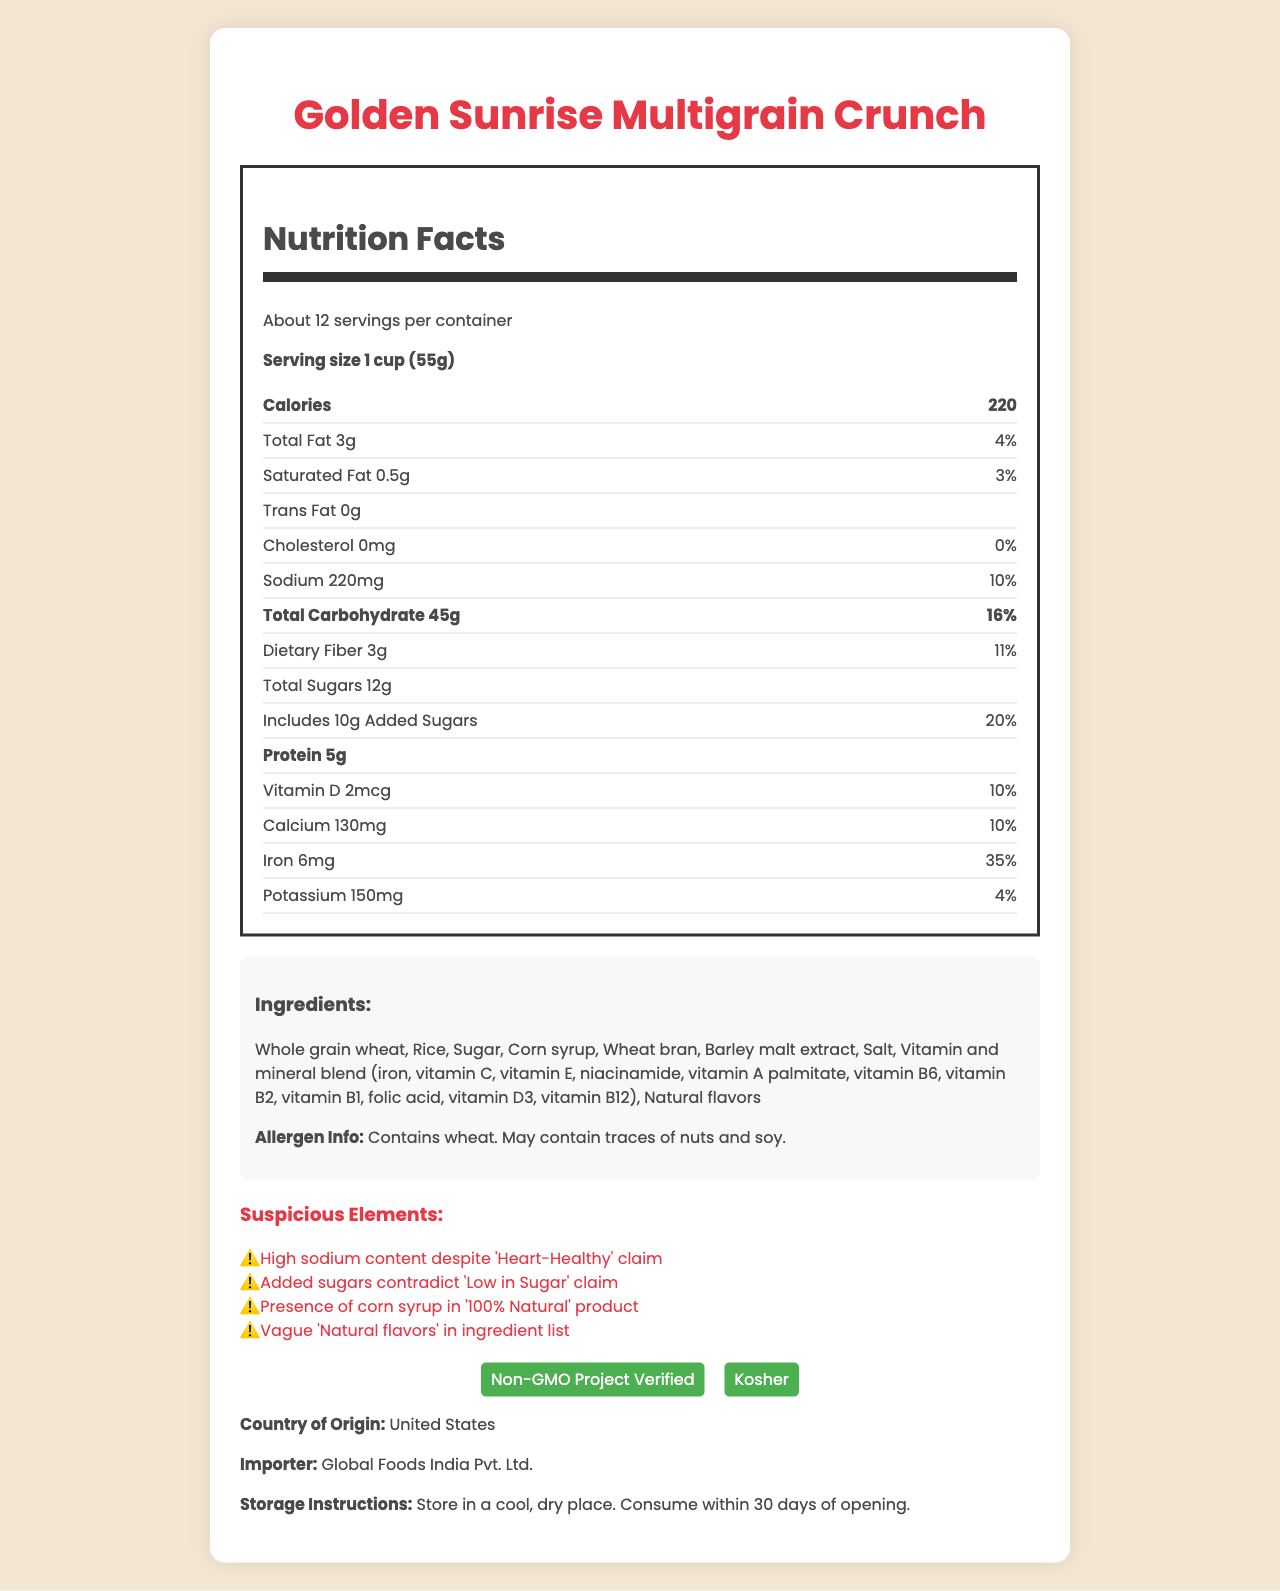what is the serving size of Golden Sunrise Multigrain Crunch? The nutrition label at the top of the document lists the serving size as "1 cup (55g)".
Answer: 1 cup (55g) how many calories are in one serving? The document states in the nutrition label section, under the heading "Calories", that each serving has 220 calories.
Answer: 220 name two certifications the product has received. The certifications section at the bottom of the document lists "Non-GMO Project Verified" and "Kosher".
Answer: Non-GMO Project Verified and Kosher what is the percentage daily value of iron per serving? Under the nutrition facts, the document lists the percent daily value for iron as 35%.
Answer: 35% how many grams of dietary fiber are there in one serving? According to the nutrition label, there are 3 grams of dietary fiber per serving.
Answer: 3g which ingredient contradicts the "100% Natural" claim? A. Whole grain wheat B. Corn syrup C. Barley malt extract D. Natural flavors One of the suspicious elements mentioned is the presence of corn syrup which contradicts the "100% Natural" claim.
Answer: B what is the country of origin of the product? A. India B. China C. United States D. Canada The document explicitly states at the bottom that the country of origin is "United States".
Answer: C does the product claim to be heart-healthy despite high sodium content? The document lists "Heart-Healthy" under misleading claims and points out high sodium content as a suspicious element.
Answer: Yes describe the main idea of the document. The document includes a nutrition facts label, lists ingredients and allergens, and mentions both certifications and misleading claims. It points out contradictions, such as high sodium content despite a heart-health claim and added sugars despite the low sugar claim.
Answer: The document provides detailed nutritional information, ingredients, certifications, and claims about Golden Sunrise Multigrain Crunch, highlighting some misleading health claims and suspicious elements. what is the exact level of cholesterol in the product? The nutrition label shows that the product contains 0mg of cholesterol per serving.
Answer: 0mg which vitamin has a 10% daily value per serving? The nutrition label lists that both Vitamin D and Calcium have a 10% daily value per serving.
Answer: Vitamin D and Calcium how much added sugar is in one serving? The nutrition label mentions that there are 10g of added sugars in one serving.
Answer: 10g are the natural flavors specified in the ingredients? The ingredients list vaguely mentions "Natural flavors" without specifying what they are, and this has been highlighted as a suspicious element.
Answer: No how many servings are in one container? A. About 10 B. About 12 C. About 15 D. About 20 The document states there are "About 12" servings per container.
Answer: B does the document detail the environmental impact of the product? The document does not provide any information related to the environmental impact of the product.
Answer: No 